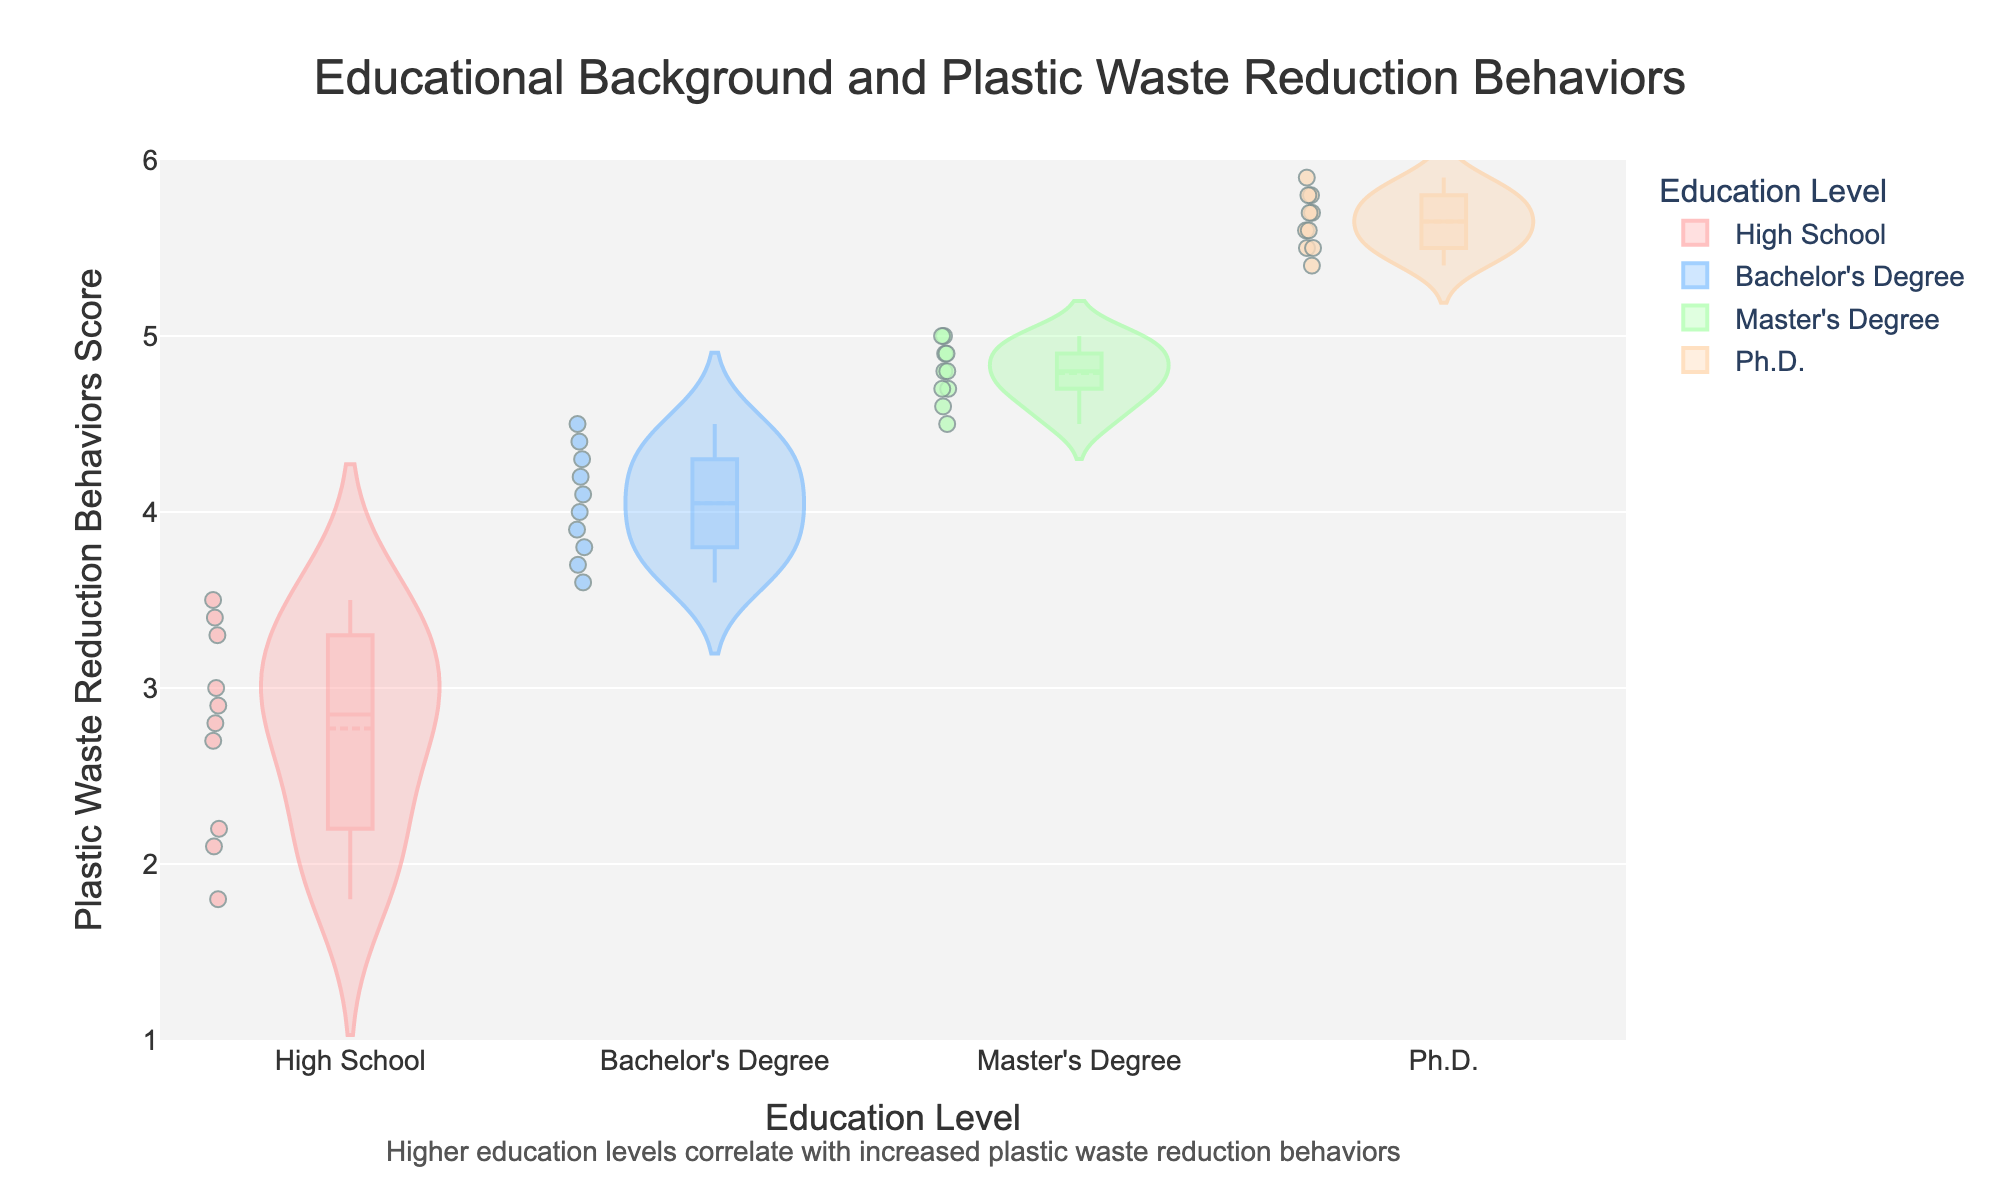what is the title of the figure? The title is usually displayed at the top of the figure. In this case, the title is "Educational Background and Plastic Waste Reduction Behaviors", which clearly summarizes the focus of the visualized data.
Answer: Educational Background and Plastic Waste Reduction Behaviors What is the y-axis title? The y-axis title is located along the vertical axis, indicating the measure being displayed on that axis. Here, it states "Plastic Waste Reduction Behaviors Score", which represents the scores assigned to the behaviors associated with reducing plastic waste.
Answer: Plastic Waste Reduction Behaviors Score Which education level group shows the highest median score for plastic waste reduction behaviors? To determine the highest median score, observe the central line inside the box plot overlay of each violin plot. The Ph.D. group has the highest median line, indicating the highest median score for plastic waste reduction behaviors.
Answer: Ph.D Which education level group has the widest spread in their plastic waste reduction behaviors? The spread of the data can be judged by the width of the violin plot. The High School group appears to have the widest spread, indicating more variability in their plastic waste reduction behaviors.
Answer: High School What does the annotation at the bottom of the figure suggest? The annotation is a text added to provide additional context or insight into the data. In this figure, it states "Higher education levels correlate with increased plastic waste reduction behaviors", indicating that individuals with higher education levels tend to show higher scores for plastic waste reduction behaviors.
Answer: Higher education levels correlate with increased plastic waste reduction behaviors How do the mean scores vary across different education levels? The mean scores can be identified by locating the mean lines (usually a different style or color) within the violin plots. Observing these, we see that the mean scores increase from High School to Bachelor's Degree to Master's Degree and finally to Ph.D., showing that higher education levels correspond to higher mean scores in plastic waste reduction behaviors.
Answer: The mean scores progressively increase with higher education levels How does the behavior score of Master's Degree holders compare to Bachelor's Degree holders? By comparing the box plots and the overall distribution within the violin plots, it is noticeable that Master's Degree holders typically have higher scores than Bachelor's Degree holders, evidenced by a higher median and overall higher data points in the Master's Degree violin plot.
Answer: Master's Degree holders have higher behavior scores What is the approximate range of plastic waste reduction behavior scores for Ph.D. holders? To find the range, we look at the spread from the minimum to the maximum score within the Ph.D. violin plot. The scores for Ph.D. holders range approximately from 5.4 to 5.9.
Answer: Approximately 5.4 to 5.9 